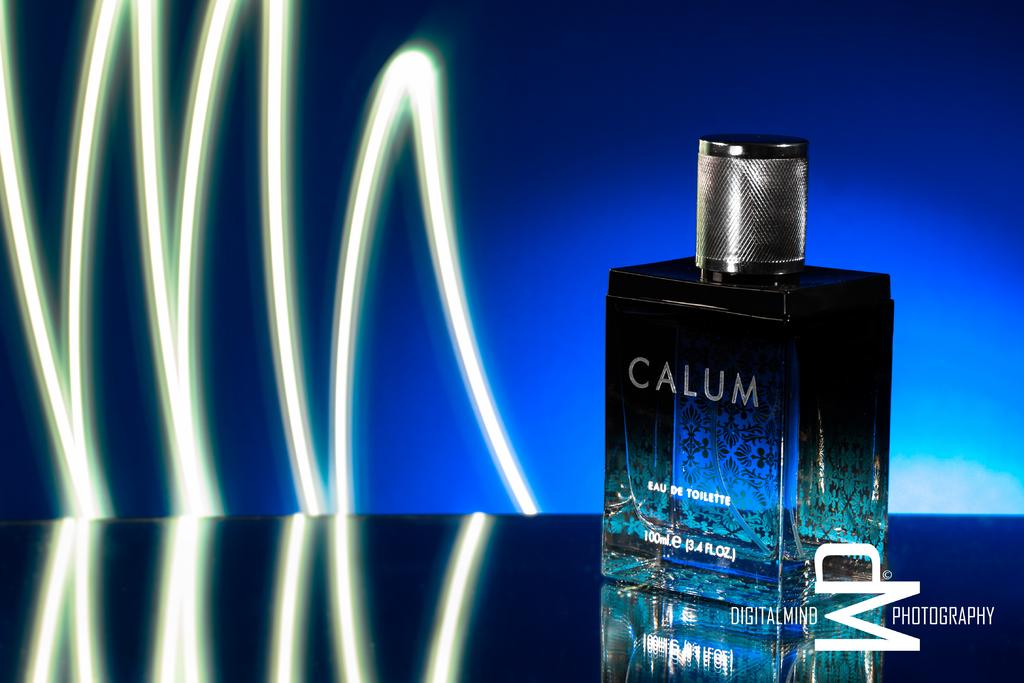What type of cologne is in the bottle?
Your answer should be very brief. Calum. Who took this photo?
Offer a terse response. Digital mind photography. 